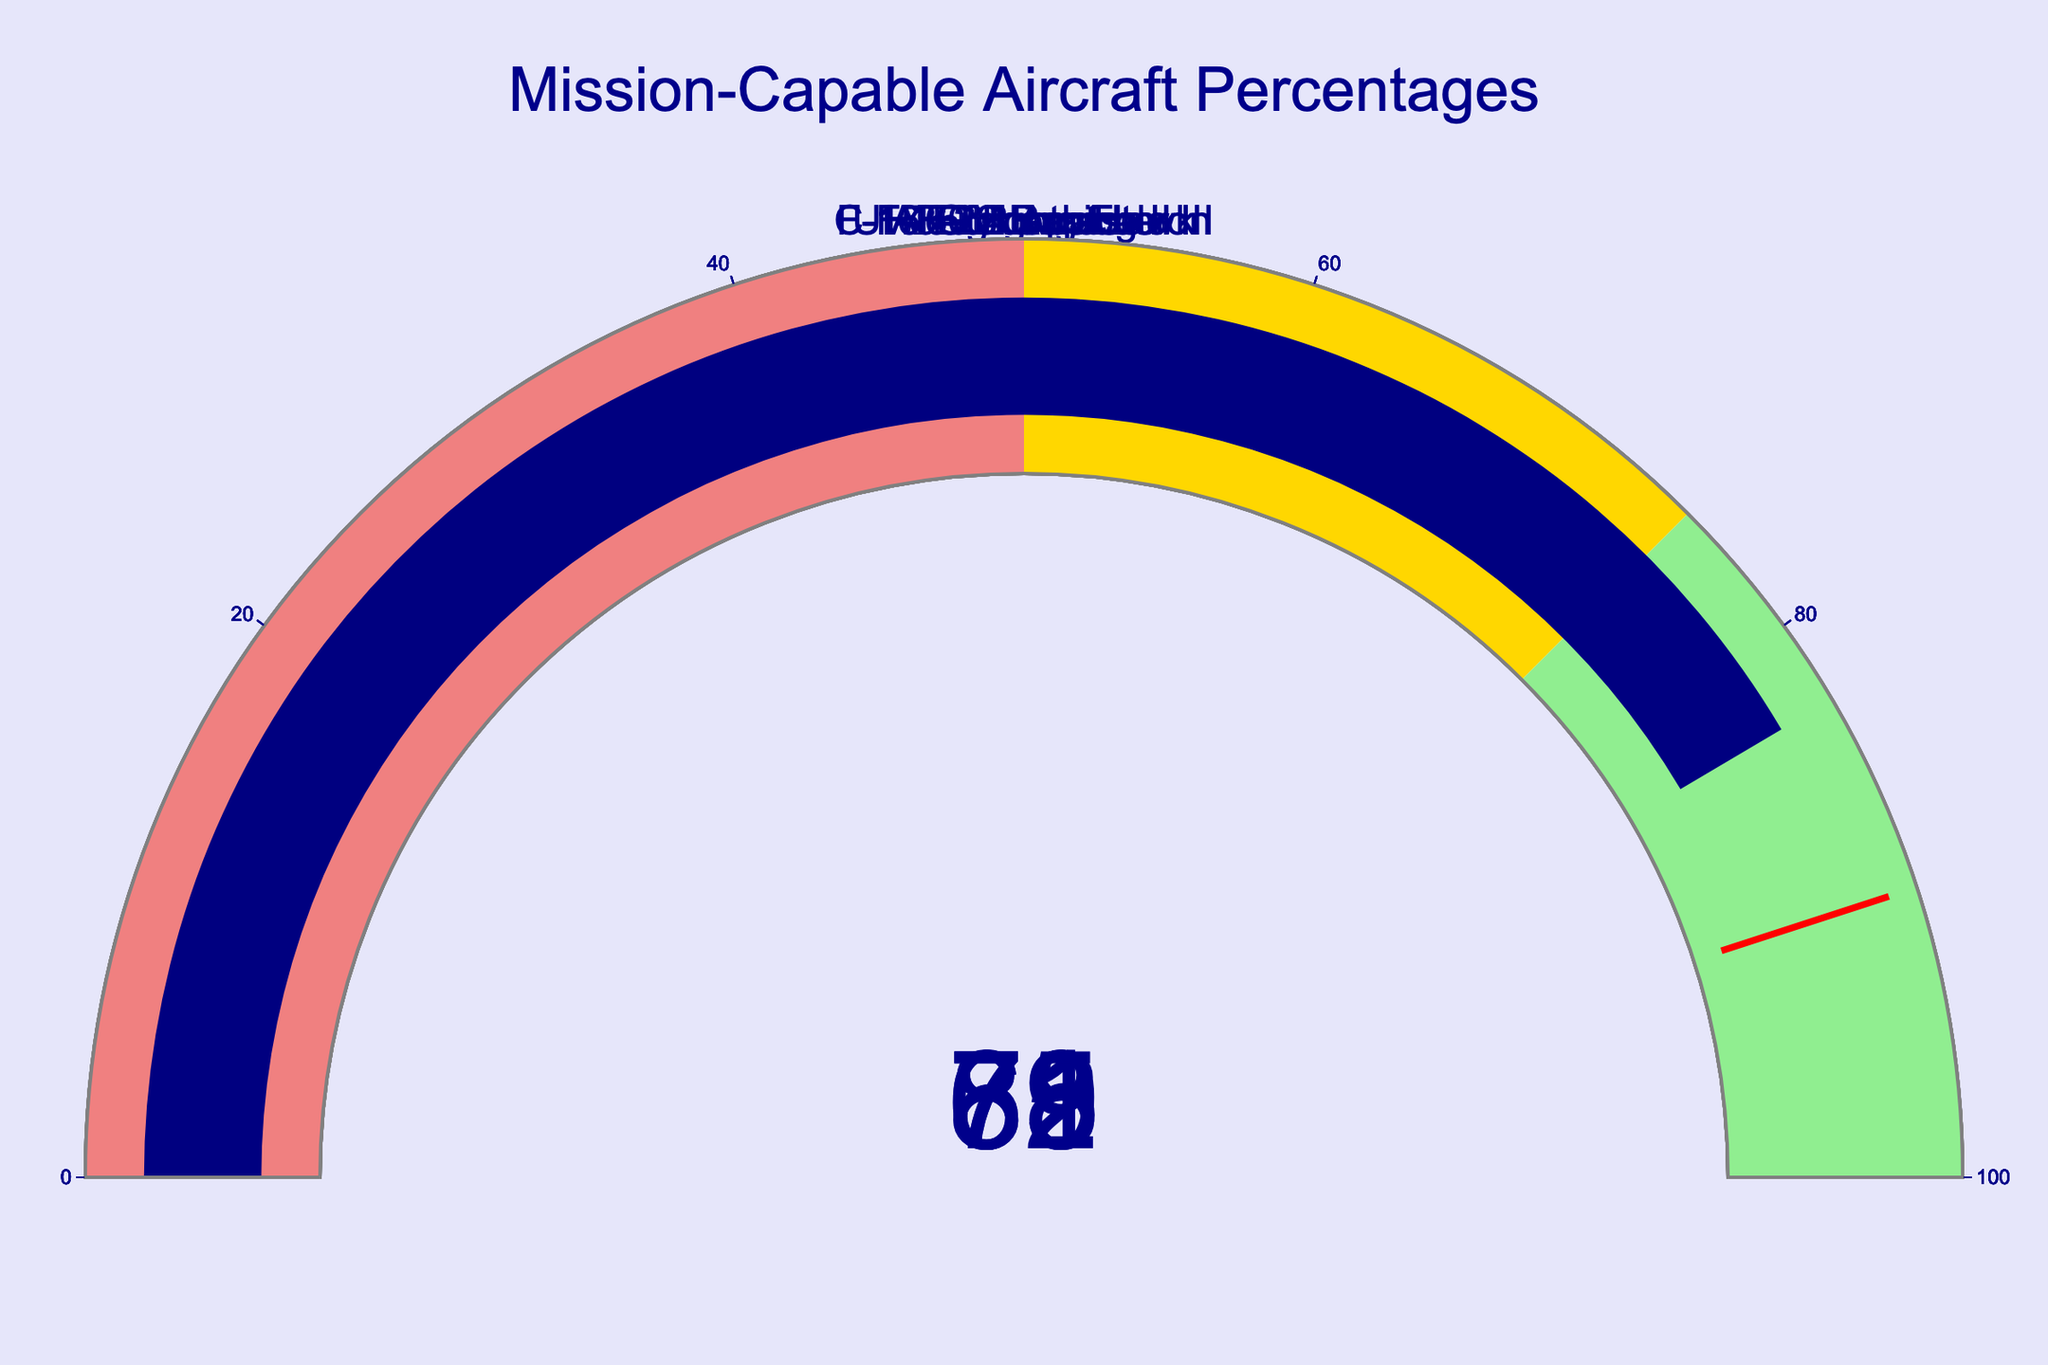What is the percentage of mission-capable F-35 Lightning II aircraft? Locate the gauge labeled "F-35 Lightning II". The number displayed on the gauge is the percentage.
Answer: 78 Which aircraft has the highest percentage of mission-capable aircraft? Compare the percentages indicated in each gauge. The C-17 Globemaster III has the highest value.
Answer: C-17 Globemaster III What is the difference in mission-capable percentages between F-22 Raptor and F-16 Fighting Falcon? Subtract the percentage of F-22 Raptor from that of F-16 Fighting Falcon (71 - 62).
Answer: 9 What is the average percentage of mission-capable aircraft for the F-35 Lightning II and the AH-64 Apache? Add the percentages of F-35 Lightning II and AH-64 Apache, then divide by 2 ((78 + 69) / 2).
Answer: 73.5 How many aircraft types have a mission-capable percentage greater than 75? Count the gauges where the display value is greater than 75. F-35 Lightning II, C-17 Globemaster III, and UH-60 Black Hawk meet this condition.
Answer: 3 Is the percentage of mission-capable F-22 Raptor aircraft in the gold range of the gauge chart? Identify the range for gold color (50-75). The F-22 Raptor has a percentage of 62, which falls within this range.
Answer: Yes Which aircraft has a percentage closest to 70? Compare all percentages to 70. The AH-64 Apache has the value closest to 70, with 69%.
Answer: AH-64 Apache What is the median percentage of mission-capable aircraft across all types? List all percentages from the gauges (78, 62, 71, 85, 69, 83), order them (62, 69, 71, 78, 83, 85), and find the middle value.
Answer: 74.5 